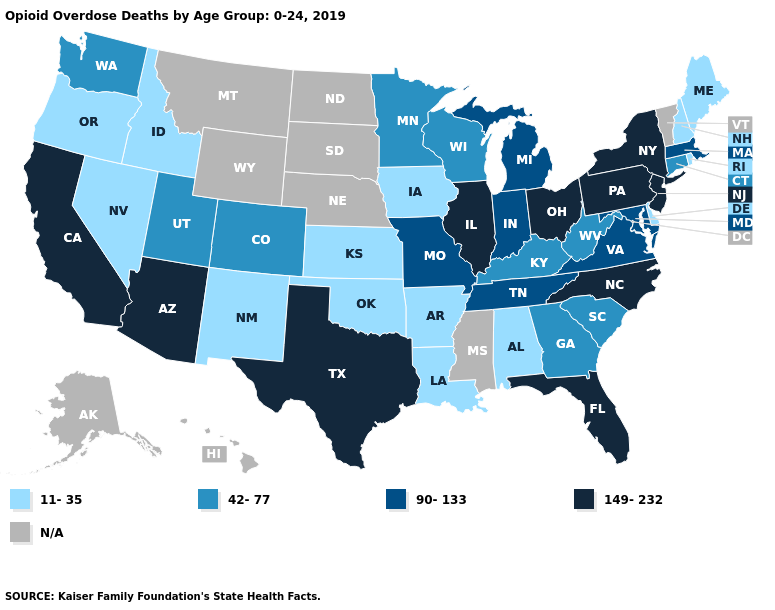What is the value of Alabama?
Give a very brief answer. 11-35. Does the map have missing data?
Keep it brief. Yes. Which states have the lowest value in the West?
Quick response, please. Idaho, Nevada, New Mexico, Oregon. What is the value of Mississippi?
Keep it brief. N/A. What is the highest value in states that border South Carolina?
Answer briefly. 149-232. Name the states that have a value in the range 90-133?
Be succinct. Indiana, Maryland, Massachusetts, Michigan, Missouri, Tennessee, Virginia. Among the states that border Missouri , which have the lowest value?
Be succinct. Arkansas, Iowa, Kansas, Oklahoma. What is the lowest value in states that border New Hampshire?
Give a very brief answer. 11-35. Name the states that have a value in the range 42-77?
Give a very brief answer. Colorado, Connecticut, Georgia, Kentucky, Minnesota, South Carolina, Utah, Washington, West Virginia, Wisconsin. Does Tennessee have the highest value in the USA?
Keep it brief. No. What is the value of Wisconsin?
Quick response, please. 42-77. What is the lowest value in the Northeast?
Write a very short answer. 11-35. Which states have the lowest value in the USA?
Be succinct. Alabama, Arkansas, Delaware, Idaho, Iowa, Kansas, Louisiana, Maine, Nevada, New Hampshire, New Mexico, Oklahoma, Oregon, Rhode Island. Name the states that have a value in the range 11-35?
Short answer required. Alabama, Arkansas, Delaware, Idaho, Iowa, Kansas, Louisiana, Maine, Nevada, New Hampshire, New Mexico, Oklahoma, Oregon, Rhode Island. What is the value of Massachusetts?
Quick response, please. 90-133. 